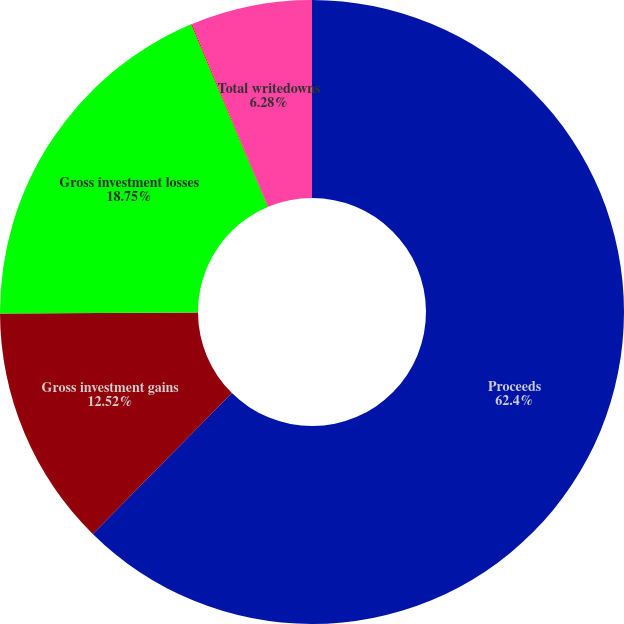Convert chart to OTSL. <chart><loc_0><loc_0><loc_500><loc_500><pie_chart><fcel>Proceeds<fcel>Gross investment gains<fcel>Gross investment losses<fcel>Credit-related<fcel>Total writedowns<nl><fcel>62.4%<fcel>12.52%<fcel>18.75%<fcel>0.05%<fcel>6.28%<nl></chart> 